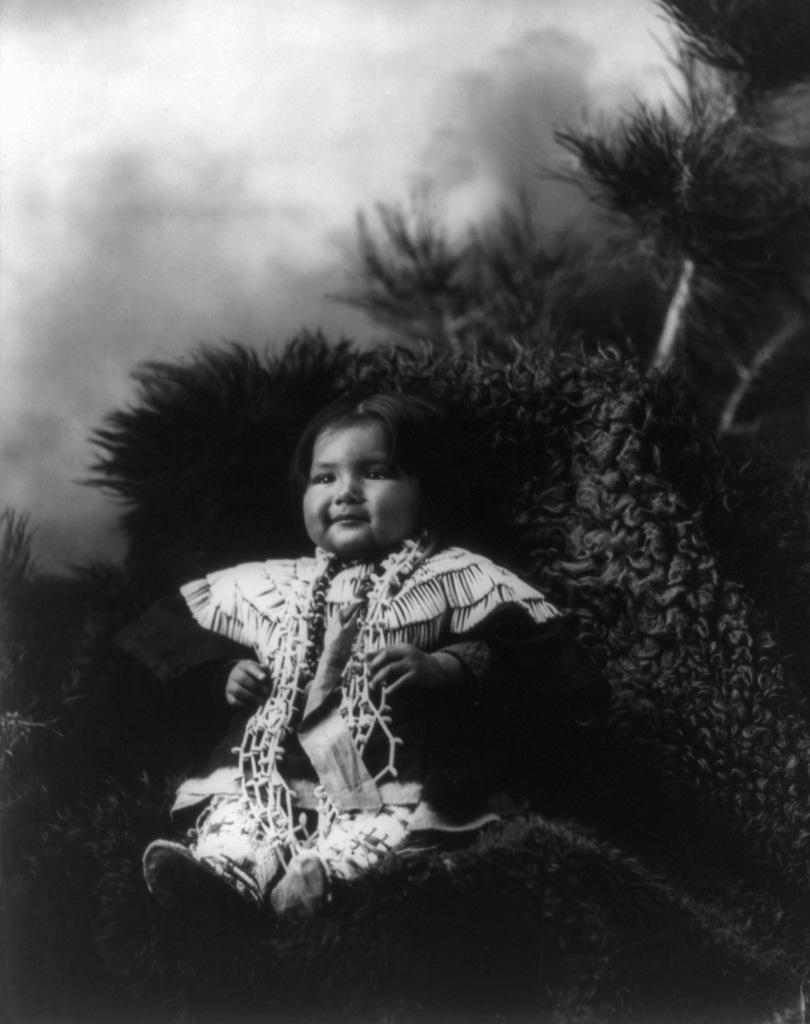Describe this image in one or two sentences. At the bottom of this image, there is a baby smiling and sitting on a surface on which there is grass. In the background, there are trees, plants and the sky. 